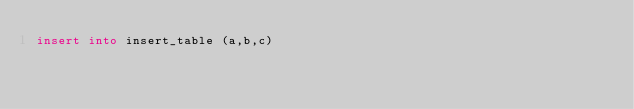<code> <loc_0><loc_0><loc_500><loc_500><_SQL_>insert into insert_table (a,b,c)
</code> 